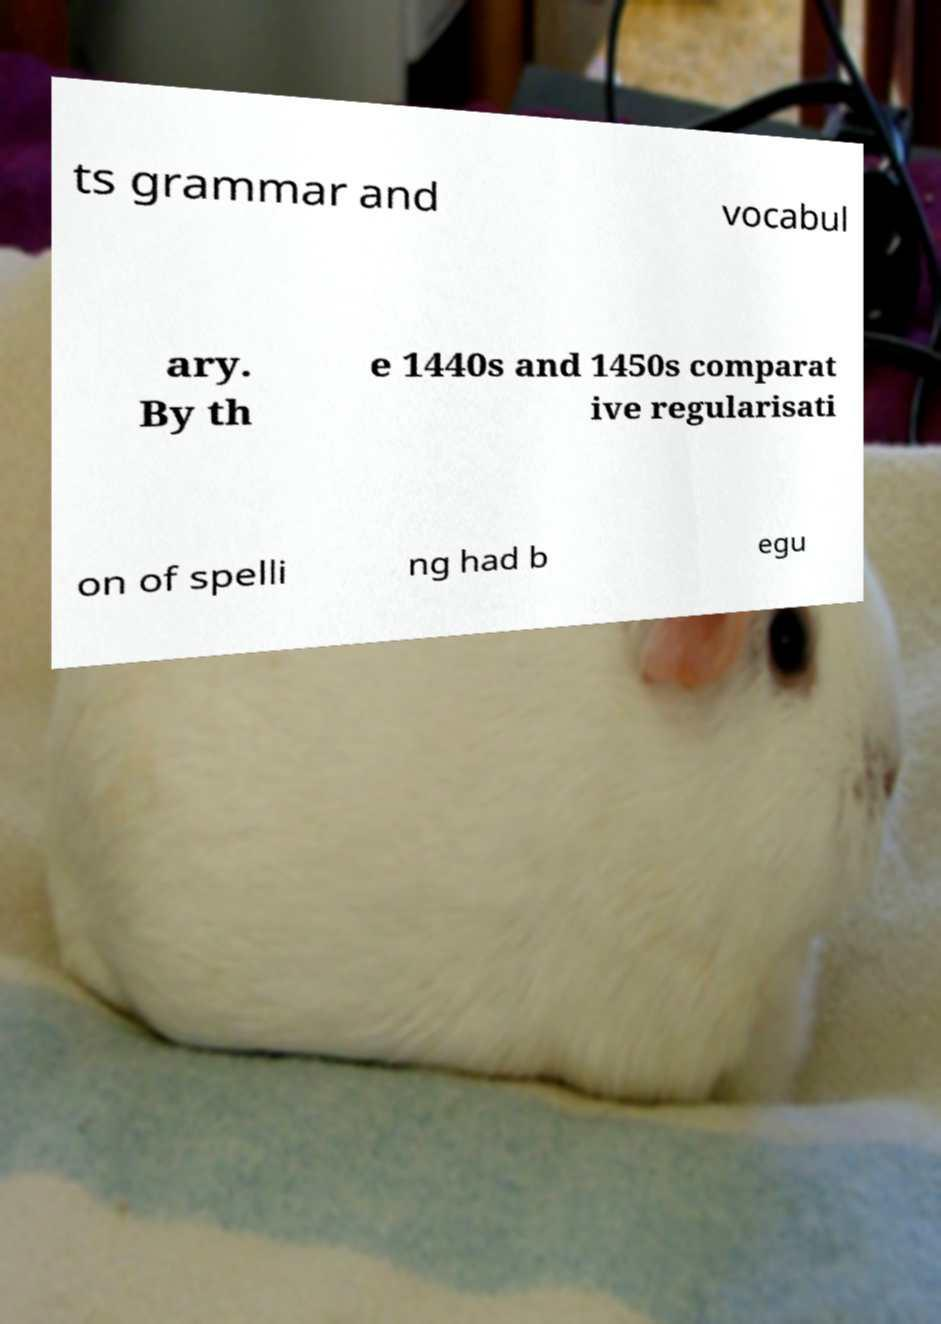I need the written content from this picture converted into text. Can you do that? ts grammar and vocabul ary. By th e 1440s and 1450s comparat ive regularisati on of spelli ng had b egu 